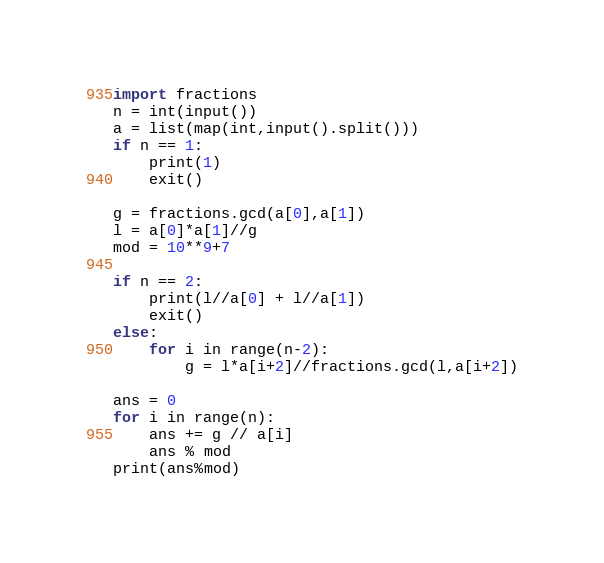Convert code to text. <code><loc_0><loc_0><loc_500><loc_500><_Python_>import fractions
n = int(input())
a = list(map(int,input().split()))
if n == 1:
    print(1)
    exit()

g = fractions.gcd(a[0],a[1])
l = a[0]*a[1]//g
mod = 10**9+7

if n == 2:
    print(l//a[0] + l//a[1])
    exit()
else:
    for i in range(n-2):
        g = l*a[i+2]//fractions.gcd(l,a[i+2])

ans = 0
for i in range(n):
    ans += g // a[i]
    ans % mod
print(ans%mod)</code> 